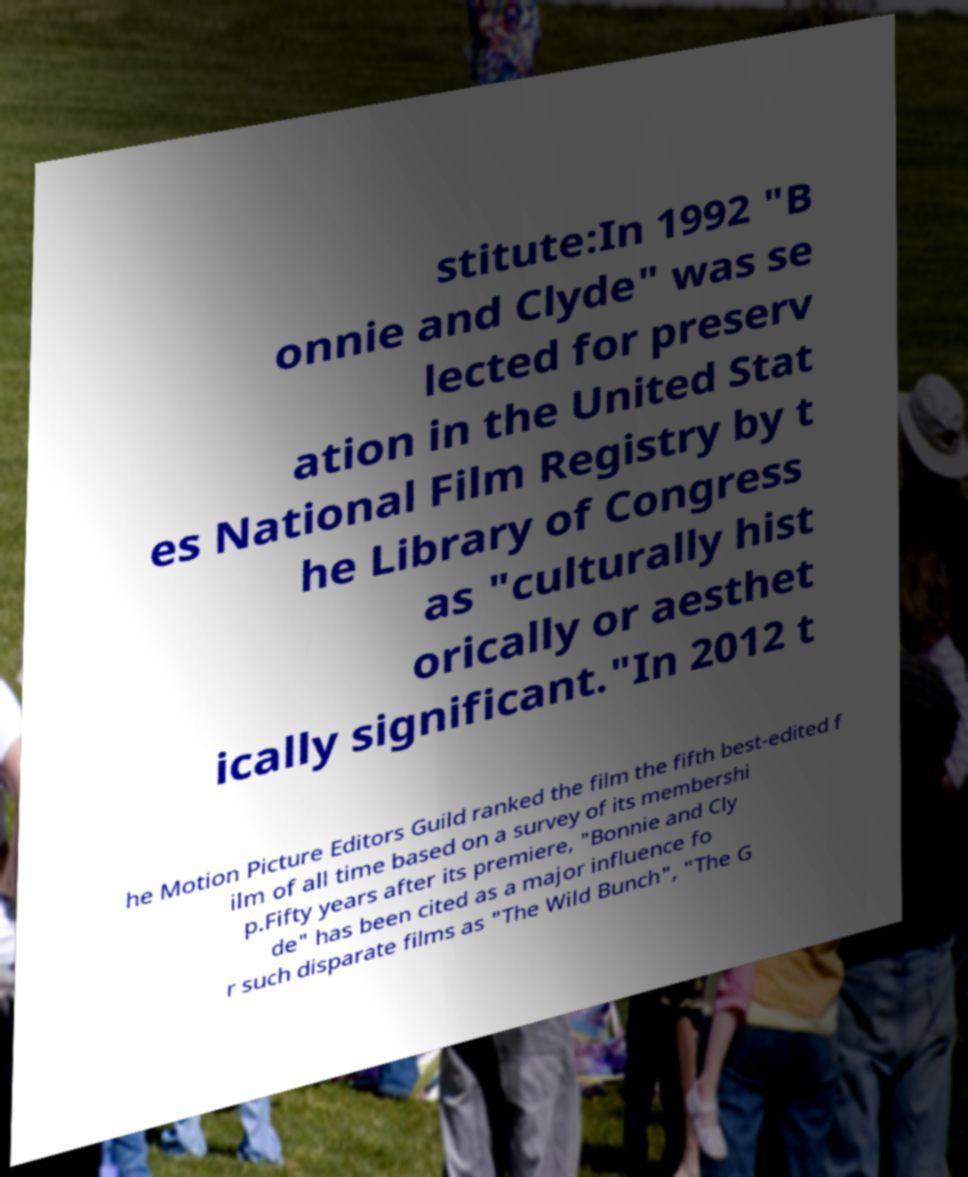What messages or text are displayed in this image? I need them in a readable, typed format. stitute:In 1992 "B onnie and Clyde" was se lected for preserv ation in the United Stat es National Film Registry by t he Library of Congress as "culturally hist orically or aesthet ically significant."In 2012 t he Motion Picture Editors Guild ranked the film the fifth best-edited f ilm of all time based on a survey of its membershi p.Fifty years after its premiere, "Bonnie and Cly de" has been cited as a major influence fo r such disparate films as "The Wild Bunch", "The G 